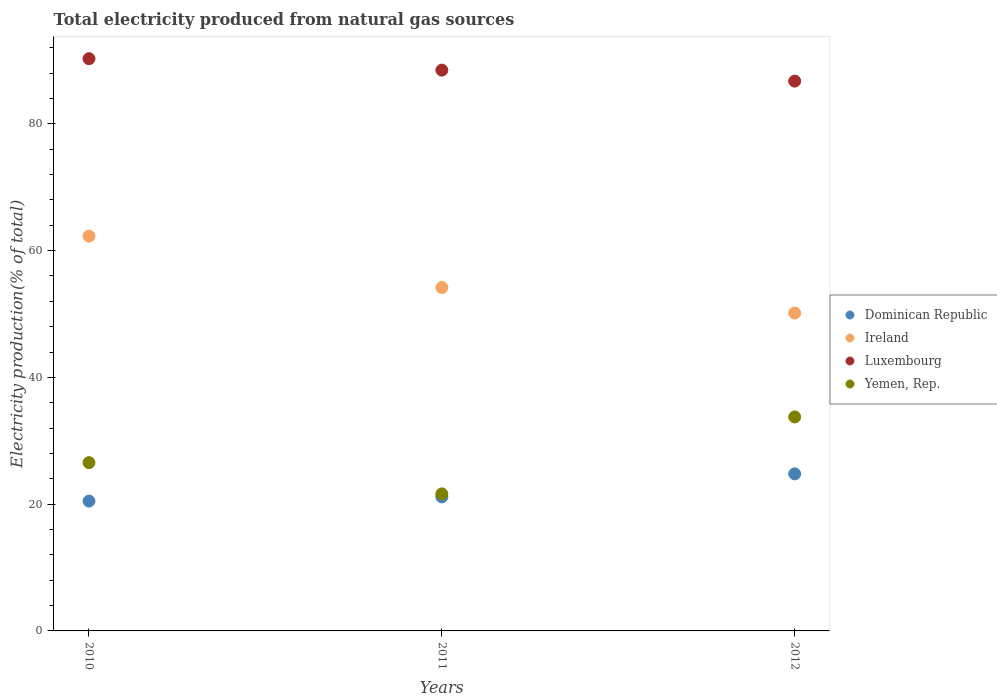What is the total electricity produced in Yemen, Rep. in 2011?
Your answer should be very brief. 21.62. Across all years, what is the maximum total electricity produced in Luxembourg?
Give a very brief answer. 90.28. Across all years, what is the minimum total electricity produced in Dominican Republic?
Provide a succinct answer. 20.49. What is the total total electricity produced in Yemen, Rep. in the graph?
Make the answer very short. 81.93. What is the difference between the total electricity produced in Yemen, Rep. in 2010 and that in 2012?
Keep it short and to the point. -7.21. What is the difference between the total electricity produced in Luxembourg in 2011 and the total electricity produced in Yemen, Rep. in 2012?
Provide a succinct answer. 54.71. What is the average total electricity produced in Luxembourg per year?
Offer a terse response. 88.5. In the year 2012, what is the difference between the total electricity produced in Luxembourg and total electricity produced in Dominican Republic?
Keep it short and to the point. 61.96. What is the ratio of the total electricity produced in Luxembourg in 2010 to that in 2011?
Your answer should be very brief. 1.02. What is the difference between the highest and the second highest total electricity produced in Ireland?
Offer a very short reply. 8.11. What is the difference between the highest and the lowest total electricity produced in Luxembourg?
Your response must be concise. 3.54. Is it the case that in every year, the sum of the total electricity produced in Dominican Republic and total electricity produced in Yemen, Rep.  is greater than the sum of total electricity produced in Luxembourg and total electricity produced in Ireland?
Your response must be concise. No. Does the total electricity produced in Yemen, Rep. monotonically increase over the years?
Offer a very short reply. No. Is the total electricity produced in Dominican Republic strictly greater than the total electricity produced in Yemen, Rep. over the years?
Provide a short and direct response. No. How many dotlines are there?
Your answer should be very brief. 4. How many years are there in the graph?
Your answer should be very brief. 3. Are the values on the major ticks of Y-axis written in scientific E-notation?
Provide a succinct answer. No. Does the graph contain any zero values?
Ensure brevity in your answer.  No. Does the graph contain grids?
Your answer should be compact. No. What is the title of the graph?
Your response must be concise. Total electricity produced from natural gas sources. Does "Sub-Saharan Africa (all income levels)" appear as one of the legend labels in the graph?
Make the answer very short. No. What is the label or title of the X-axis?
Offer a terse response. Years. What is the label or title of the Y-axis?
Offer a terse response. Electricity production(% of total). What is the Electricity production(% of total) in Dominican Republic in 2010?
Your answer should be very brief. 20.49. What is the Electricity production(% of total) in Ireland in 2010?
Offer a very short reply. 62.29. What is the Electricity production(% of total) of Luxembourg in 2010?
Give a very brief answer. 90.28. What is the Electricity production(% of total) of Yemen, Rep. in 2010?
Make the answer very short. 26.55. What is the Electricity production(% of total) in Dominican Republic in 2011?
Your answer should be very brief. 21.15. What is the Electricity production(% of total) in Ireland in 2011?
Make the answer very short. 54.18. What is the Electricity production(% of total) in Luxembourg in 2011?
Provide a succinct answer. 88.47. What is the Electricity production(% of total) of Yemen, Rep. in 2011?
Your response must be concise. 21.62. What is the Electricity production(% of total) in Dominican Republic in 2012?
Your response must be concise. 24.78. What is the Electricity production(% of total) of Ireland in 2012?
Your response must be concise. 50.15. What is the Electricity production(% of total) of Luxembourg in 2012?
Ensure brevity in your answer.  86.74. What is the Electricity production(% of total) of Yemen, Rep. in 2012?
Provide a succinct answer. 33.76. Across all years, what is the maximum Electricity production(% of total) of Dominican Republic?
Your answer should be very brief. 24.78. Across all years, what is the maximum Electricity production(% of total) of Ireland?
Give a very brief answer. 62.29. Across all years, what is the maximum Electricity production(% of total) in Luxembourg?
Offer a very short reply. 90.28. Across all years, what is the maximum Electricity production(% of total) of Yemen, Rep.?
Ensure brevity in your answer.  33.76. Across all years, what is the minimum Electricity production(% of total) of Dominican Republic?
Keep it short and to the point. 20.49. Across all years, what is the minimum Electricity production(% of total) of Ireland?
Keep it short and to the point. 50.15. Across all years, what is the minimum Electricity production(% of total) of Luxembourg?
Your response must be concise. 86.74. Across all years, what is the minimum Electricity production(% of total) of Yemen, Rep.?
Offer a very short reply. 21.62. What is the total Electricity production(% of total) in Dominican Republic in the graph?
Your response must be concise. 66.41. What is the total Electricity production(% of total) of Ireland in the graph?
Give a very brief answer. 166.62. What is the total Electricity production(% of total) of Luxembourg in the graph?
Ensure brevity in your answer.  265.49. What is the total Electricity production(% of total) of Yemen, Rep. in the graph?
Ensure brevity in your answer.  81.93. What is the difference between the Electricity production(% of total) in Dominican Republic in 2010 and that in 2011?
Offer a terse response. -0.66. What is the difference between the Electricity production(% of total) in Ireland in 2010 and that in 2011?
Provide a short and direct response. 8.11. What is the difference between the Electricity production(% of total) of Luxembourg in 2010 and that in 2011?
Your response must be concise. 1.81. What is the difference between the Electricity production(% of total) of Yemen, Rep. in 2010 and that in 2011?
Provide a short and direct response. 4.93. What is the difference between the Electricity production(% of total) of Dominican Republic in 2010 and that in 2012?
Ensure brevity in your answer.  -4.29. What is the difference between the Electricity production(% of total) in Ireland in 2010 and that in 2012?
Offer a terse response. 12.13. What is the difference between the Electricity production(% of total) in Luxembourg in 2010 and that in 2012?
Your answer should be very brief. 3.54. What is the difference between the Electricity production(% of total) in Yemen, Rep. in 2010 and that in 2012?
Give a very brief answer. -7.21. What is the difference between the Electricity production(% of total) in Dominican Republic in 2011 and that in 2012?
Provide a short and direct response. -3.63. What is the difference between the Electricity production(% of total) of Ireland in 2011 and that in 2012?
Ensure brevity in your answer.  4.03. What is the difference between the Electricity production(% of total) of Luxembourg in 2011 and that in 2012?
Your answer should be compact. 1.73. What is the difference between the Electricity production(% of total) in Yemen, Rep. in 2011 and that in 2012?
Your answer should be compact. -12.13. What is the difference between the Electricity production(% of total) in Dominican Republic in 2010 and the Electricity production(% of total) in Ireland in 2011?
Give a very brief answer. -33.69. What is the difference between the Electricity production(% of total) of Dominican Republic in 2010 and the Electricity production(% of total) of Luxembourg in 2011?
Make the answer very short. -67.99. What is the difference between the Electricity production(% of total) of Dominican Republic in 2010 and the Electricity production(% of total) of Yemen, Rep. in 2011?
Your answer should be compact. -1.14. What is the difference between the Electricity production(% of total) of Ireland in 2010 and the Electricity production(% of total) of Luxembourg in 2011?
Give a very brief answer. -26.19. What is the difference between the Electricity production(% of total) in Ireland in 2010 and the Electricity production(% of total) in Yemen, Rep. in 2011?
Ensure brevity in your answer.  40.66. What is the difference between the Electricity production(% of total) in Luxembourg in 2010 and the Electricity production(% of total) in Yemen, Rep. in 2011?
Your response must be concise. 68.65. What is the difference between the Electricity production(% of total) in Dominican Republic in 2010 and the Electricity production(% of total) in Ireland in 2012?
Offer a terse response. -29.67. What is the difference between the Electricity production(% of total) in Dominican Republic in 2010 and the Electricity production(% of total) in Luxembourg in 2012?
Your answer should be compact. -66.26. What is the difference between the Electricity production(% of total) in Dominican Republic in 2010 and the Electricity production(% of total) in Yemen, Rep. in 2012?
Your answer should be very brief. -13.27. What is the difference between the Electricity production(% of total) of Ireland in 2010 and the Electricity production(% of total) of Luxembourg in 2012?
Keep it short and to the point. -24.45. What is the difference between the Electricity production(% of total) of Ireland in 2010 and the Electricity production(% of total) of Yemen, Rep. in 2012?
Your answer should be very brief. 28.53. What is the difference between the Electricity production(% of total) of Luxembourg in 2010 and the Electricity production(% of total) of Yemen, Rep. in 2012?
Give a very brief answer. 56.52. What is the difference between the Electricity production(% of total) of Dominican Republic in 2011 and the Electricity production(% of total) of Ireland in 2012?
Keep it short and to the point. -29.01. What is the difference between the Electricity production(% of total) in Dominican Republic in 2011 and the Electricity production(% of total) in Luxembourg in 2012?
Your answer should be very brief. -65.6. What is the difference between the Electricity production(% of total) in Dominican Republic in 2011 and the Electricity production(% of total) in Yemen, Rep. in 2012?
Offer a very short reply. -12.61. What is the difference between the Electricity production(% of total) of Ireland in 2011 and the Electricity production(% of total) of Luxembourg in 2012?
Give a very brief answer. -32.56. What is the difference between the Electricity production(% of total) of Ireland in 2011 and the Electricity production(% of total) of Yemen, Rep. in 2012?
Keep it short and to the point. 20.42. What is the difference between the Electricity production(% of total) in Luxembourg in 2011 and the Electricity production(% of total) in Yemen, Rep. in 2012?
Provide a succinct answer. 54.71. What is the average Electricity production(% of total) in Dominican Republic per year?
Keep it short and to the point. 22.14. What is the average Electricity production(% of total) of Ireland per year?
Provide a short and direct response. 55.54. What is the average Electricity production(% of total) of Luxembourg per year?
Ensure brevity in your answer.  88.5. What is the average Electricity production(% of total) in Yemen, Rep. per year?
Provide a short and direct response. 27.31. In the year 2010, what is the difference between the Electricity production(% of total) of Dominican Republic and Electricity production(% of total) of Ireland?
Offer a terse response. -41.8. In the year 2010, what is the difference between the Electricity production(% of total) of Dominican Republic and Electricity production(% of total) of Luxembourg?
Provide a short and direct response. -69.79. In the year 2010, what is the difference between the Electricity production(% of total) in Dominican Republic and Electricity production(% of total) in Yemen, Rep.?
Your answer should be very brief. -6.06. In the year 2010, what is the difference between the Electricity production(% of total) of Ireland and Electricity production(% of total) of Luxembourg?
Your response must be concise. -27.99. In the year 2010, what is the difference between the Electricity production(% of total) in Ireland and Electricity production(% of total) in Yemen, Rep.?
Offer a terse response. 35.74. In the year 2010, what is the difference between the Electricity production(% of total) in Luxembourg and Electricity production(% of total) in Yemen, Rep.?
Your response must be concise. 63.73. In the year 2011, what is the difference between the Electricity production(% of total) in Dominican Republic and Electricity production(% of total) in Ireland?
Ensure brevity in your answer.  -33.03. In the year 2011, what is the difference between the Electricity production(% of total) of Dominican Republic and Electricity production(% of total) of Luxembourg?
Ensure brevity in your answer.  -67.33. In the year 2011, what is the difference between the Electricity production(% of total) of Dominican Republic and Electricity production(% of total) of Yemen, Rep.?
Keep it short and to the point. -0.48. In the year 2011, what is the difference between the Electricity production(% of total) in Ireland and Electricity production(% of total) in Luxembourg?
Offer a terse response. -34.29. In the year 2011, what is the difference between the Electricity production(% of total) of Ireland and Electricity production(% of total) of Yemen, Rep.?
Your response must be concise. 32.55. In the year 2011, what is the difference between the Electricity production(% of total) of Luxembourg and Electricity production(% of total) of Yemen, Rep.?
Ensure brevity in your answer.  66.85. In the year 2012, what is the difference between the Electricity production(% of total) of Dominican Republic and Electricity production(% of total) of Ireland?
Keep it short and to the point. -25.37. In the year 2012, what is the difference between the Electricity production(% of total) of Dominican Republic and Electricity production(% of total) of Luxembourg?
Give a very brief answer. -61.96. In the year 2012, what is the difference between the Electricity production(% of total) of Dominican Republic and Electricity production(% of total) of Yemen, Rep.?
Your response must be concise. -8.98. In the year 2012, what is the difference between the Electricity production(% of total) of Ireland and Electricity production(% of total) of Luxembourg?
Offer a terse response. -36.59. In the year 2012, what is the difference between the Electricity production(% of total) of Ireland and Electricity production(% of total) of Yemen, Rep.?
Ensure brevity in your answer.  16.39. In the year 2012, what is the difference between the Electricity production(% of total) of Luxembourg and Electricity production(% of total) of Yemen, Rep.?
Offer a very short reply. 52.98. What is the ratio of the Electricity production(% of total) of Dominican Republic in 2010 to that in 2011?
Provide a succinct answer. 0.97. What is the ratio of the Electricity production(% of total) of Ireland in 2010 to that in 2011?
Make the answer very short. 1.15. What is the ratio of the Electricity production(% of total) in Luxembourg in 2010 to that in 2011?
Ensure brevity in your answer.  1.02. What is the ratio of the Electricity production(% of total) of Yemen, Rep. in 2010 to that in 2011?
Make the answer very short. 1.23. What is the ratio of the Electricity production(% of total) in Dominican Republic in 2010 to that in 2012?
Give a very brief answer. 0.83. What is the ratio of the Electricity production(% of total) of Ireland in 2010 to that in 2012?
Ensure brevity in your answer.  1.24. What is the ratio of the Electricity production(% of total) of Luxembourg in 2010 to that in 2012?
Ensure brevity in your answer.  1.04. What is the ratio of the Electricity production(% of total) in Yemen, Rep. in 2010 to that in 2012?
Provide a succinct answer. 0.79. What is the ratio of the Electricity production(% of total) in Dominican Republic in 2011 to that in 2012?
Keep it short and to the point. 0.85. What is the ratio of the Electricity production(% of total) in Ireland in 2011 to that in 2012?
Your answer should be compact. 1.08. What is the ratio of the Electricity production(% of total) in Luxembourg in 2011 to that in 2012?
Keep it short and to the point. 1.02. What is the ratio of the Electricity production(% of total) of Yemen, Rep. in 2011 to that in 2012?
Ensure brevity in your answer.  0.64. What is the difference between the highest and the second highest Electricity production(% of total) in Dominican Republic?
Ensure brevity in your answer.  3.63. What is the difference between the highest and the second highest Electricity production(% of total) of Ireland?
Provide a short and direct response. 8.11. What is the difference between the highest and the second highest Electricity production(% of total) of Luxembourg?
Provide a succinct answer. 1.81. What is the difference between the highest and the second highest Electricity production(% of total) in Yemen, Rep.?
Make the answer very short. 7.21. What is the difference between the highest and the lowest Electricity production(% of total) in Dominican Republic?
Your answer should be very brief. 4.29. What is the difference between the highest and the lowest Electricity production(% of total) of Ireland?
Your response must be concise. 12.13. What is the difference between the highest and the lowest Electricity production(% of total) of Luxembourg?
Your response must be concise. 3.54. What is the difference between the highest and the lowest Electricity production(% of total) in Yemen, Rep.?
Ensure brevity in your answer.  12.13. 